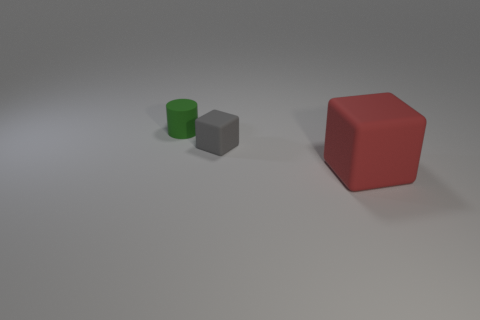Add 3 tiny cubes. How many objects exist? 6 Subtract all cylinders. How many objects are left? 2 Subtract 0 gray spheres. How many objects are left? 3 Subtract all green matte things. Subtract all tiny things. How many objects are left? 0 Add 2 red blocks. How many red blocks are left? 3 Add 2 yellow rubber objects. How many yellow rubber objects exist? 2 